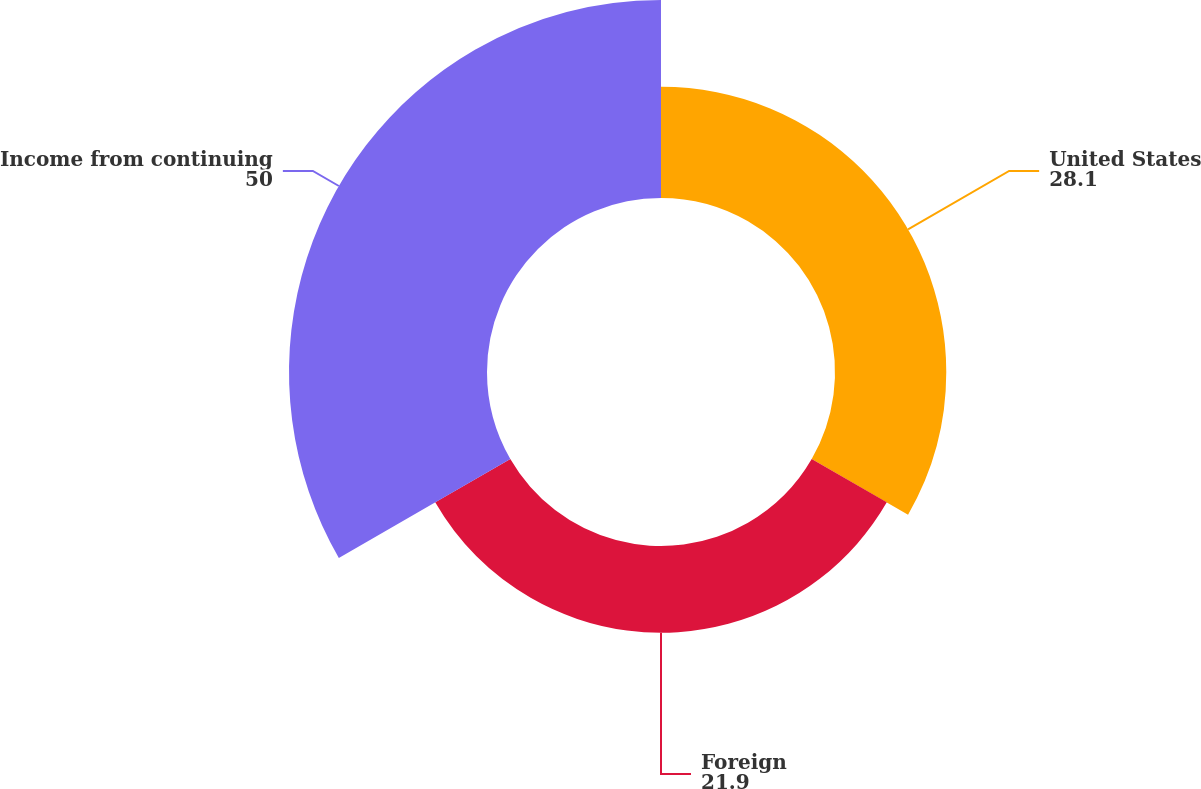Convert chart. <chart><loc_0><loc_0><loc_500><loc_500><pie_chart><fcel>United States<fcel>Foreign<fcel>Income from continuing<nl><fcel>28.1%<fcel>21.9%<fcel>50.0%<nl></chart> 